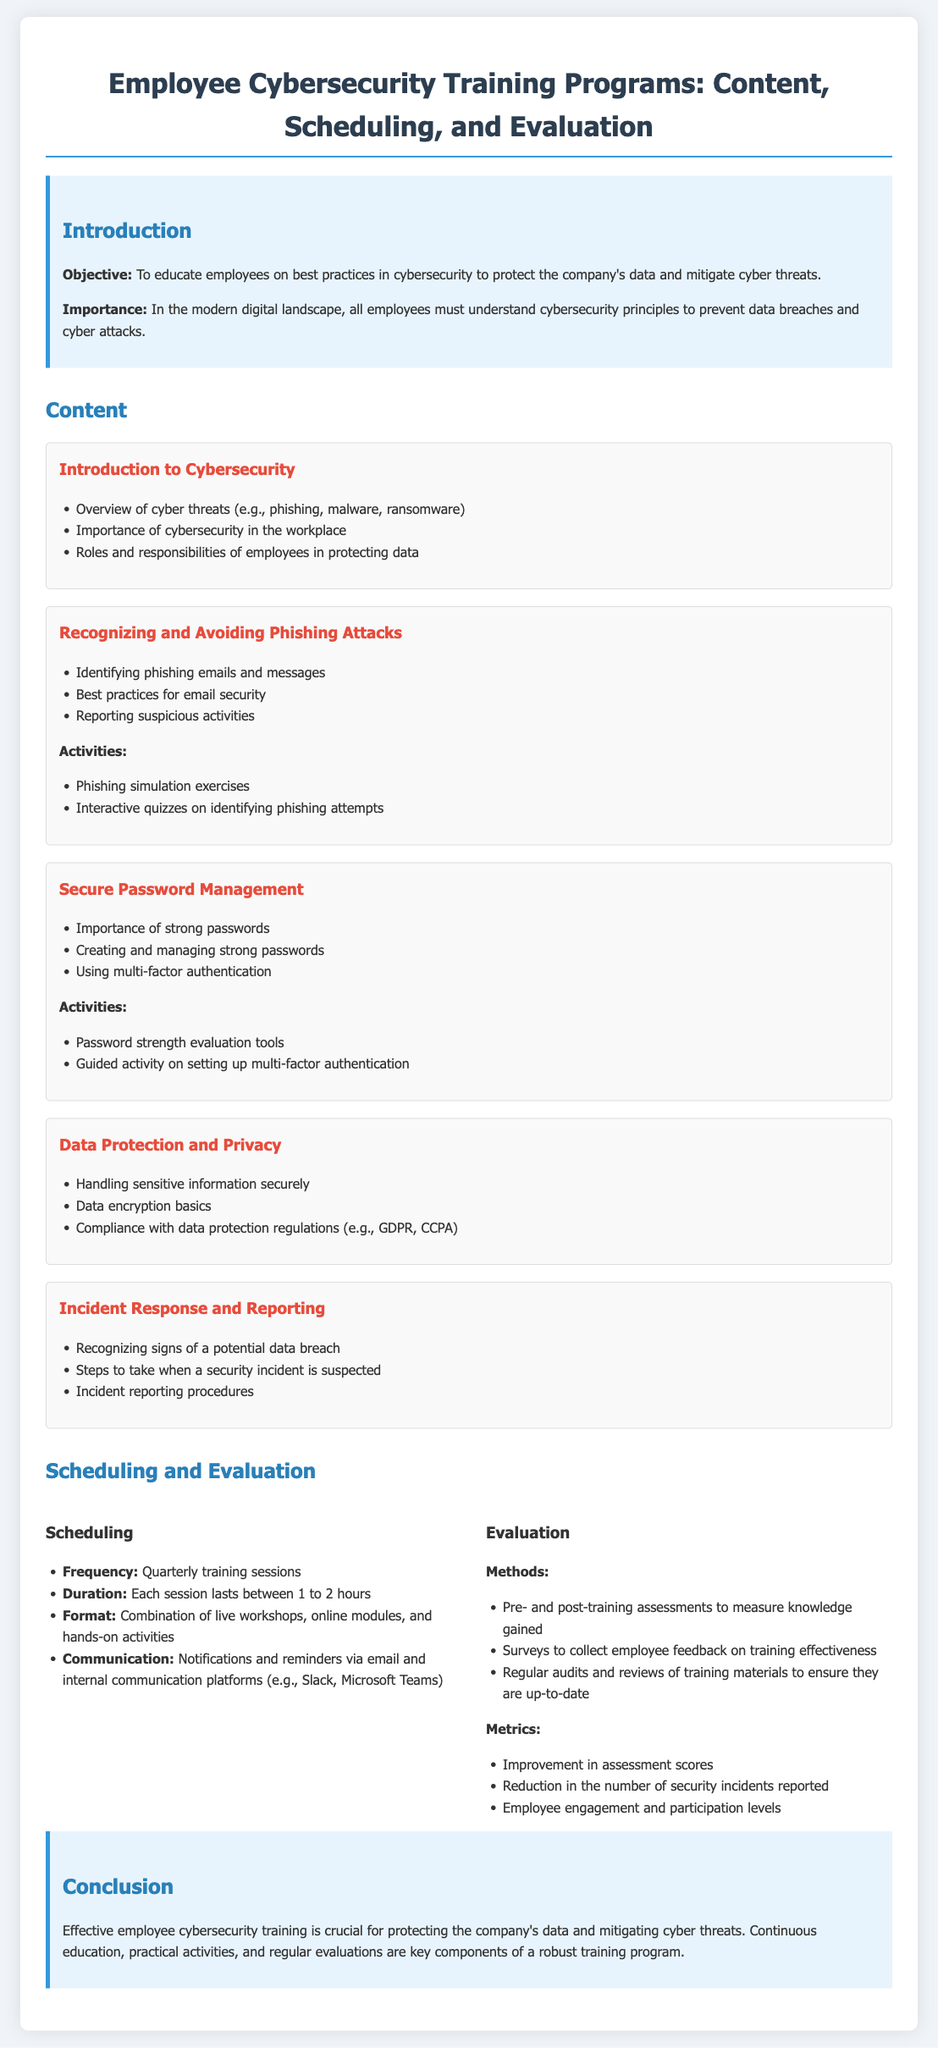What is the objective of the training program? The objective is to educate employees on best practices in cybersecurity to protect the company's data and mitigate cyber threats.
Answer: To educate employees on best practices in cybersecurity to protect the company's data and mitigate cyber threats How frequently are the training sessions held? The frequency of the training sessions is stated in the scheduling section.
Answer: Quarterly training sessions What is the duration of each training session? The duration of each session is indicated in the scheduling section.
Answer: 1 to 2 hours What is one of the activities included in the phishing module? The activities for the phishing module are listed in the content section.
Answer: Phishing simulation exercises Which regulation is mentioned in the data protection module? The compliance with data protection regulations is provided in the content section.
Answer: GDPR, CCPA What methods are used to evaluate the training? The methods for evaluation are detailed in the evaluation section of the document.
Answer: Pre- and post-training assessments What is a key component of a robust training program mentioned in the conclusion? The conclusion summarizes essential components of an effective training program.
Answer: Continuous education How is employee feedback collected? The collection method for employee feedback is specified in the evaluation section.
Answer: Surveys What is the importance of cybersecurity highlighted in the introduction? The importance of cybersecurity is specified in the introduction of the document.
Answer: To prevent data breaches and cyber attacks 